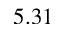Convert formula to latex. <formula><loc_0><loc_0><loc_500><loc_500>5 . 3 1</formula> 